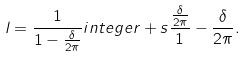Convert formula to latex. <formula><loc_0><loc_0><loc_500><loc_500>l = \frac { 1 } { 1 - \frac { \delta } { 2 \pi } } i n t e g e r + s \frac { \frac { \delta } { 2 \pi } } 1 - \frac { \delta } { 2 \pi } .</formula> 